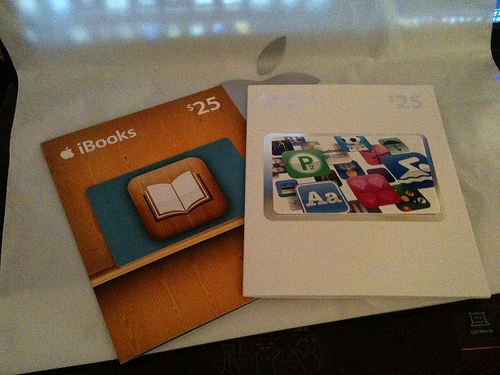<image>
Is the book on the card? Yes. Looking at the image, I can see the book is positioned on top of the card, with the card providing support. 